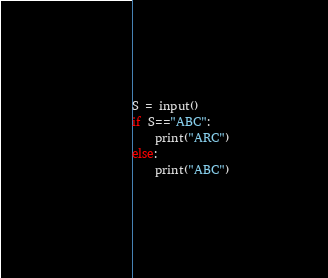Convert code to text. <code><loc_0><loc_0><loc_500><loc_500><_Python_>S = input()
if S=="ABC":
    print("ARC")
else:
    print("ABC")</code> 